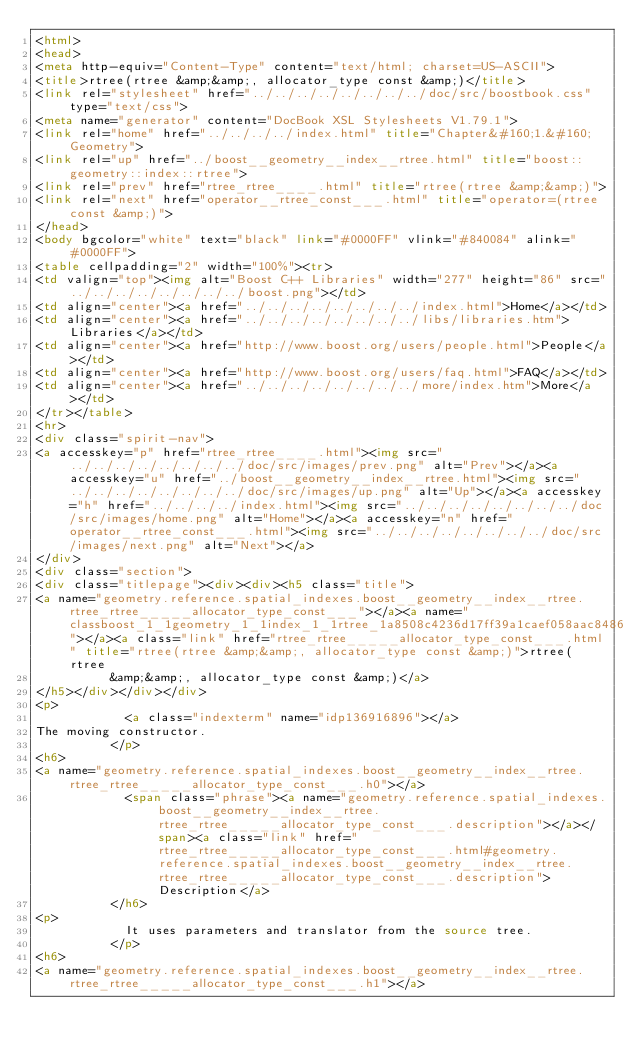<code> <loc_0><loc_0><loc_500><loc_500><_HTML_><html>
<head>
<meta http-equiv="Content-Type" content="text/html; charset=US-ASCII">
<title>rtree(rtree &amp;&amp;, allocator_type const &amp;)</title>
<link rel="stylesheet" href="../../../../../../../../doc/src/boostbook.css" type="text/css">
<meta name="generator" content="DocBook XSL Stylesheets V1.79.1">
<link rel="home" href="../../../../index.html" title="Chapter&#160;1.&#160;Geometry">
<link rel="up" href="../boost__geometry__index__rtree.html" title="boost::geometry::index::rtree">
<link rel="prev" href="rtree_rtree____.html" title="rtree(rtree &amp;&amp;)">
<link rel="next" href="operator__rtree_const___.html" title="operator=(rtree const &amp;)">
</head>
<body bgcolor="white" text="black" link="#0000FF" vlink="#840084" alink="#0000FF">
<table cellpadding="2" width="100%"><tr>
<td valign="top"><img alt="Boost C++ Libraries" width="277" height="86" src="../../../../../../../../boost.png"></td>
<td align="center"><a href="../../../../../../../../index.html">Home</a></td>
<td align="center"><a href="../../../../../../../../libs/libraries.htm">Libraries</a></td>
<td align="center"><a href="http://www.boost.org/users/people.html">People</a></td>
<td align="center"><a href="http://www.boost.org/users/faq.html">FAQ</a></td>
<td align="center"><a href="../../../../../../../../more/index.htm">More</a></td>
</tr></table>
<hr>
<div class="spirit-nav">
<a accesskey="p" href="rtree_rtree____.html"><img src="../../../../../../../../doc/src/images/prev.png" alt="Prev"></a><a accesskey="u" href="../boost__geometry__index__rtree.html"><img src="../../../../../../../../doc/src/images/up.png" alt="Up"></a><a accesskey="h" href="../../../../index.html"><img src="../../../../../../../../doc/src/images/home.png" alt="Home"></a><a accesskey="n" href="operator__rtree_const___.html"><img src="../../../../../../../../doc/src/images/next.png" alt="Next"></a>
</div>
<div class="section">
<div class="titlepage"><div><div><h5 class="title">
<a name="geometry.reference.spatial_indexes.boost__geometry__index__rtree.rtree_rtree_____allocator_type_const___"></a><a name="classboost_1_1geometry_1_1index_1_1rtree_1a8508c4236d17ff39a1caef058aac8486"></a><a class="link" href="rtree_rtree_____allocator_type_const___.html" title="rtree(rtree &amp;&amp;, allocator_type const &amp;)">rtree(rtree
          &amp;&amp;, allocator_type const &amp;)</a>
</h5></div></div></div>
<p>
            <a class="indexterm" name="idp136916896"></a>
The moving constructor.
          </p>
<h6>
<a name="geometry.reference.spatial_indexes.boost__geometry__index__rtree.rtree_rtree_____allocator_type_const___.h0"></a>
            <span class="phrase"><a name="geometry.reference.spatial_indexes.boost__geometry__index__rtree.rtree_rtree_____allocator_type_const___.description"></a></span><a class="link" href="rtree_rtree_____allocator_type_const___.html#geometry.reference.spatial_indexes.boost__geometry__index__rtree.rtree_rtree_____allocator_type_const___.description">Description</a>
          </h6>
<p>
            It uses parameters and translator from the source tree.
          </p>
<h6>
<a name="geometry.reference.spatial_indexes.boost__geometry__index__rtree.rtree_rtree_____allocator_type_const___.h1"></a></code> 